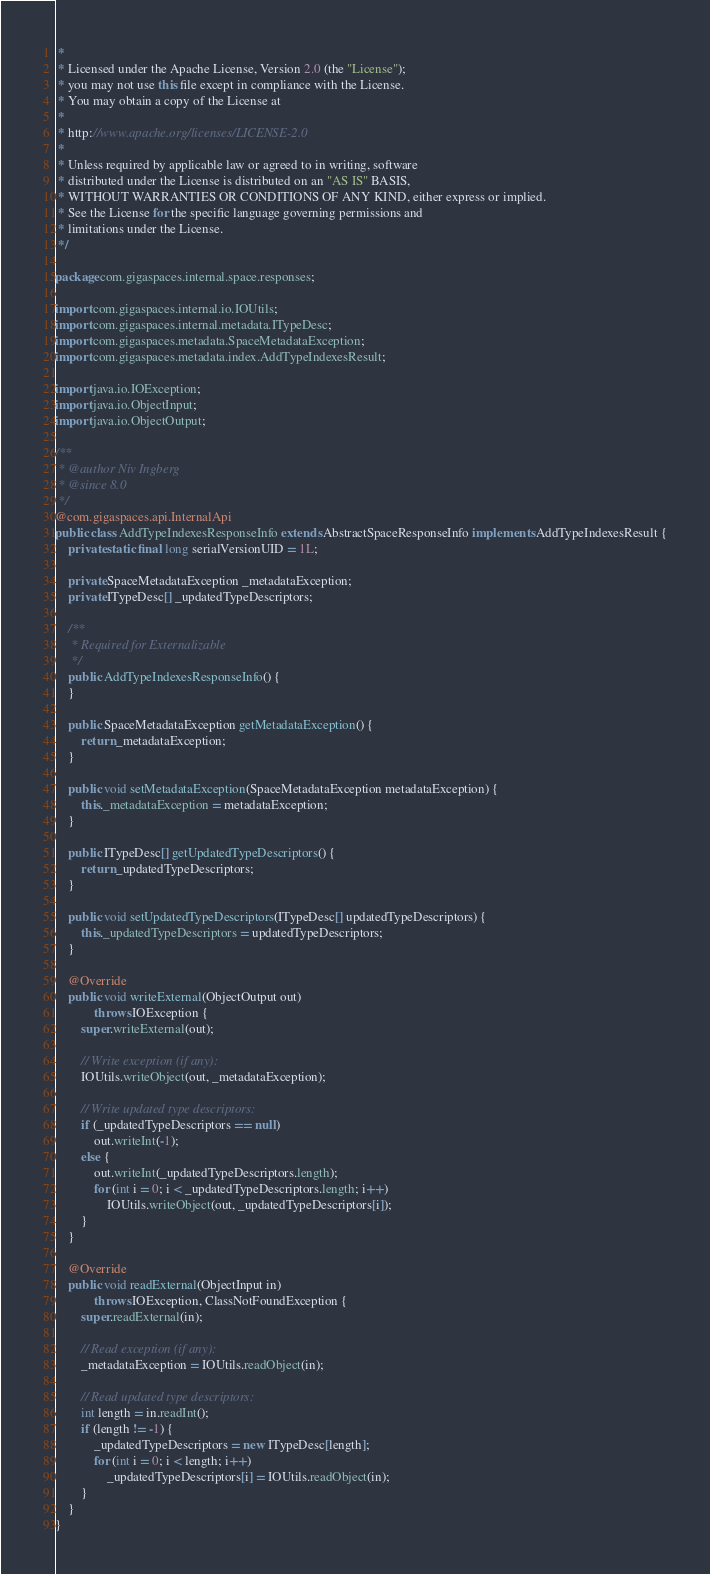Convert code to text. <code><loc_0><loc_0><loc_500><loc_500><_Java_> *
 * Licensed under the Apache License, Version 2.0 (the "License");
 * you may not use this file except in compliance with the License.
 * You may obtain a copy of the License at
 *
 * http://www.apache.org/licenses/LICENSE-2.0
 *
 * Unless required by applicable law or agreed to in writing, software
 * distributed under the License is distributed on an "AS IS" BASIS,
 * WITHOUT WARRANTIES OR CONDITIONS OF ANY KIND, either express or implied.
 * See the License for the specific language governing permissions and
 * limitations under the License.
 */

package com.gigaspaces.internal.space.responses;

import com.gigaspaces.internal.io.IOUtils;
import com.gigaspaces.internal.metadata.ITypeDesc;
import com.gigaspaces.metadata.SpaceMetadataException;
import com.gigaspaces.metadata.index.AddTypeIndexesResult;

import java.io.IOException;
import java.io.ObjectInput;
import java.io.ObjectOutput;

/**
 * @author Niv Ingberg
 * @since 8.0
 */
@com.gigaspaces.api.InternalApi
public class AddTypeIndexesResponseInfo extends AbstractSpaceResponseInfo implements AddTypeIndexesResult {
    private static final long serialVersionUID = 1L;

    private SpaceMetadataException _metadataException;
    private ITypeDesc[] _updatedTypeDescriptors;

    /**
     * Required for Externalizable
     */
    public AddTypeIndexesResponseInfo() {
    }

    public SpaceMetadataException getMetadataException() {
        return _metadataException;
    }

    public void setMetadataException(SpaceMetadataException metadataException) {
        this._metadataException = metadataException;
    }

    public ITypeDesc[] getUpdatedTypeDescriptors() {
        return _updatedTypeDescriptors;
    }

    public void setUpdatedTypeDescriptors(ITypeDesc[] updatedTypeDescriptors) {
        this._updatedTypeDescriptors = updatedTypeDescriptors;
    }

    @Override
    public void writeExternal(ObjectOutput out)
            throws IOException {
        super.writeExternal(out);

        // Write exception (if any):
        IOUtils.writeObject(out, _metadataException);

        // Write updated type descriptors:
        if (_updatedTypeDescriptors == null)
            out.writeInt(-1);
        else {
            out.writeInt(_updatedTypeDescriptors.length);
            for (int i = 0; i < _updatedTypeDescriptors.length; i++)
                IOUtils.writeObject(out, _updatedTypeDescriptors[i]);
        }
    }

    @Override
    public void readExternal(ObjectInput in)
            throws IOException, ClassNotFoundException {
        super.readExternal(in);

        // Read exception (if any):
        _metadataException = IOUtils.readObject(in);

        // Read updated type descriptors:
        int length = in.readInt();
        if (length != -1) {
            _updatedTypeDescriptors = new ITypeDesc[length];
            for (int i = 0; i < length; i++)
                _updatedTypeDescriptors[i] = IOUtils.readObject(in);
        }
    }
}
</code> 